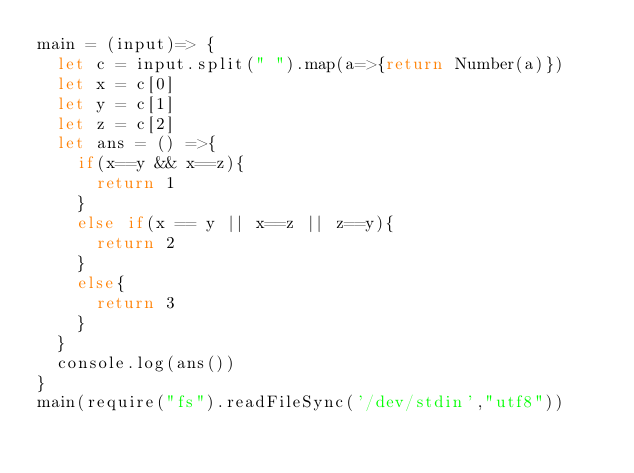Convert code to text. <code><loc_0><loc_0><loc_500><loc_500><_JavaScript_>main = (input)=> {
  let c = input.split(" ").map(a=>{return Number(a)})
  let x = c[0]
  let y = c[1]
  let z = c[2]
  let ans = () =>{
    if(x==y && x==z){
      return 1
    }
    else if(x == y || x==z || z==y){
      return 2
    }
    else{
      return 3
    }
  }
  console.log(ans())
}
main(require("fs").readFileSync('/dev/stdin',"utf8"))</code> 